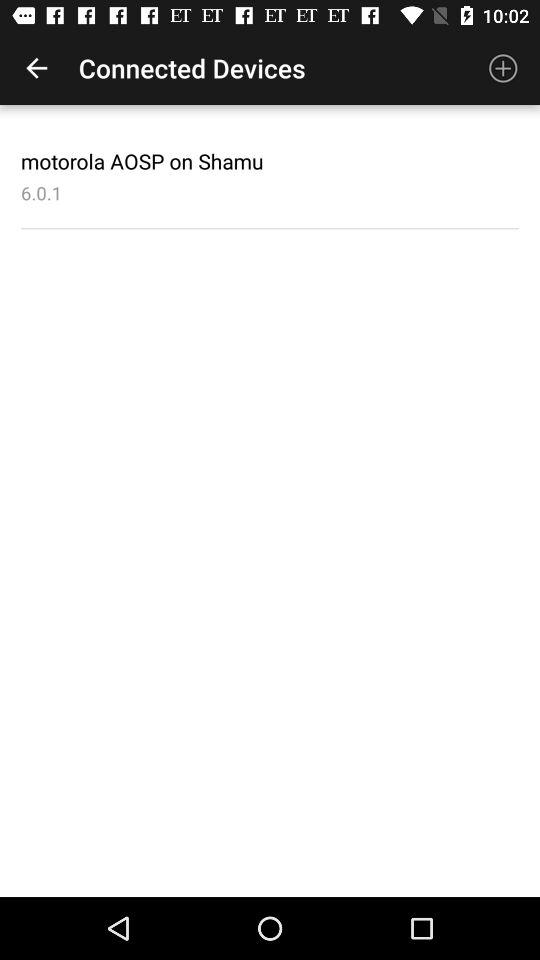What is the version? The version is 6.0.1. 